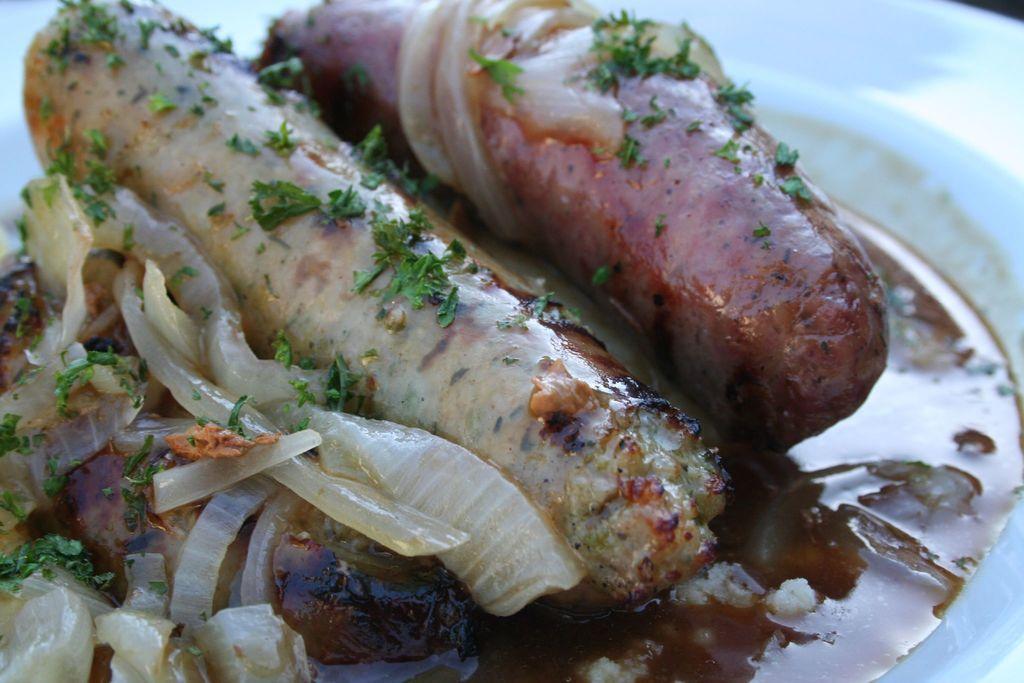Can you describe this image briefly? In this image we can see a plate of food with the sausages. 